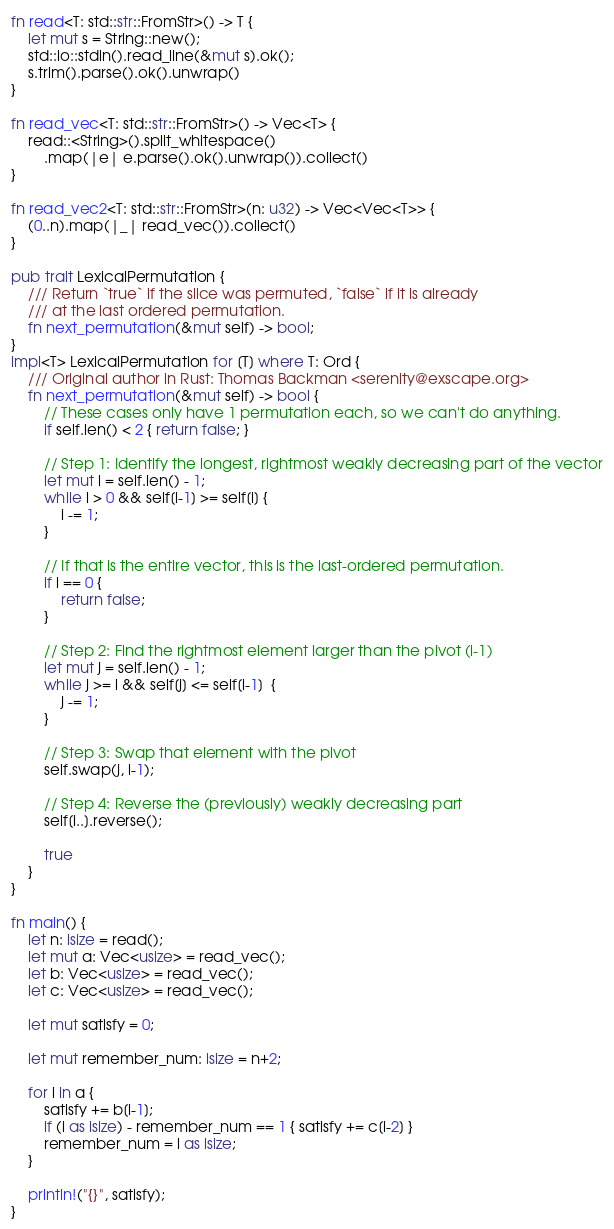<code> <loc_0><loc_0><loc_500><loc_500><_Rust_>fn read<T: std::str::FromStr>() -> T {
	let mut s = String::new();
	std::io::stdin().read_line(&mut s).ok();
	s.trim().parse().ok().unwrap()
}

fn read_vec<T: std::str::FromStr>() -> Vec<T> {
	read::<String>().split_whitespace()
		.map(|e| e.parse().ok().unwrap()).collect()
}

fn read_vec2<T: std::str::FromStr>(n: u32) -> Vec<Vec<T>> {
	(0..n).map(|_| read_vec()).collect()
}

pub trait LexicalPermutation {
	/// Return `true` if the slice was permuted, `false` if it is already
	/// at the last ordered permutation.
	fn next_permutation(&mut self) -> bool;
}
impl<T> LexicalPermutation for [T] where T: Ord {
	/// Original author in Rust: Thomas Backman <serenity@exscape.org>
	fn next_permutation(&mut self) -> bool {
		// These cases only have 1 permutation each, so we can't do anything.
		if self.len() < 2 { return false; }

		// Step 1: Identify the longest, rightmost weakly decreasing part of the vector
		let mut i = self.len() - 1;
		while i > 0 && self[i-1] >= self[i] {
			i -= 1;
		}

		// If that is the entire vector, this is the last-ordered permutation.
		if i == 0 {
			return false;
		}

		// Step 2: Find the rightmost element larger than the pivot (i-1)
		let mut j = self.len() - 1;
		while j >= i && self[j] <= self[i-1]  {
			j -= 1;
		}

		// Step 3: Swap that element with the pivot
		self.swap(j, i-1);

		// Step 4: Reverse the (previously) weakly decreasing part
		self[i..].reverse();

		true
	}
}

fn main() {
	let n: isize = read();
	let mut a: Vec<usize> = read_vec();
	let b: Vec<usize> = read_vec();
	let c: Vec<usize> = read_vec();

	let mut satisfy = 0;

	let mut remember_num: isize = n+2;

	for i in a {
		satisfy += b[i-1];
		if (i as isize) - remember_num == 1 { satisfy += c[i-2] }
		remember_num = i as isize;
	}

	println!("{}", satisfy);
}
</code> 